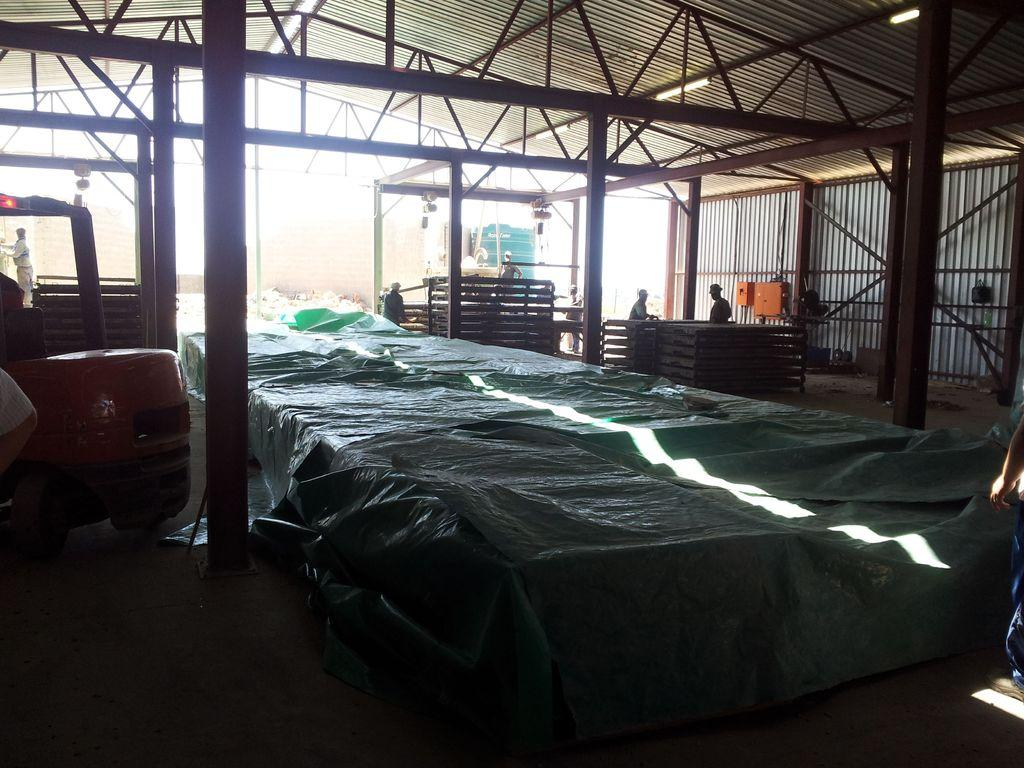What is the setting of the image? The image shows the inside view of a shed. Are there any people present in the shed? Yes, there are people in the shed. What type of material is used for the strings in the shed? The strings in the shed are made of iron. What structural elements can be seen in the shed? There are pillars in the shed. What other objects are present in the shed besides the people and strings? There are other objects in the shed. What can be seen on the left side of the image? There appears to be a vehicle on the left side of the image. What color are the shoes worn by the people in the image? There is no mention of shoes in the image, so we cannot determine their color. 